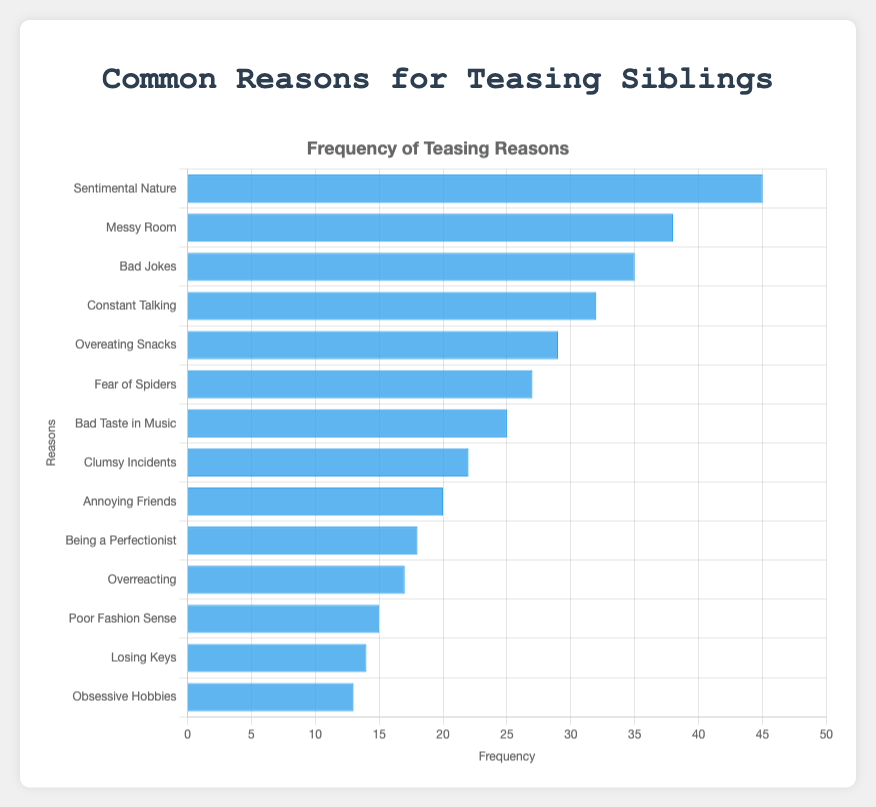Which reason is the most common for teasing siblings? The reason "Sentimental Nature" has the highest bar in the chart, indicating it has the highest frequency of 45.
Answer: Sentimental Nature What is the difference in occurrence frequency between "Sentimental Nature" and "Overreacting"? "Sentimental Nature" has a frequency of 45 and "Overreacting" has a frequency of 17. Subtracting 17 from 45 gives 28.
Answer: 28 What are the three least common reasons for teasing siblings? From the chart, the reasons with the smallest bars are "Obsessive Hobbies", "Losing Keys", and "Poor Fashion Sense" with frequencies of 13, 14, and 15, respectively.
Answer: Obsessive Hobbies, Losing Keys, Poor Fashion Sense How much more frequently is "Messy Room" teased compared to "Fear of Spiders"? The frequency of "Messy Room" is 38, while the frequency of "Fear of Spiders" is 27. The difference is 38 - 27 = 11.
Answer: 11 Which reason is teased more, "Bad Jokes" or "Constant Talking"? The bar for "Bad Jokes" is higher than the bar for "Constant Talking." "Bad Jokes" has a frequency of 35, whereas "Constant Talking" has a frequency of 32.
Answer: Bad Jokes What is the total frequency for the top 3 reasons for teasing siblings? The top 3 reasons are "Sentimental Nature" (45), "Messy Room" (38), and "Bad Jokes" (35). The total is 45 + 38 + 35 = 118.
Answer: 118 Is "Overeating Snacks" teased more frequently than "Clumsy Incidents"? The frequency of "Overeating Snacks" is 29, while the frequency for "Clumsy Incidents" is 22. Since 29 is greater than 22, "Overeating Snacks" is teased more frequently.
Answer: Yes What is the average frequency of all reasons listed? Sum all the frequencies and then divide by the number of reasons. The sum is 45+38+35+32+29+27+25+22+20+18+17+15+14+13 = 350. There are 14 reasons, so the average is 350/14 ≈ 25.
Answer: 25 Which reason falls in the middle (median) in terms of frequency? Listing the frequencies in ascending order: 13, 14, 15, 17, 18, 20, 22, 25, 27, 29, 32, 35, 38, 45. The median is the average of the 7th and 8th values: (22+25)/2 = 23.5.
Answer: 23.5 What is the combined frequency of the reasons that have a frequency above 30? The reasons are "Sentimental Nature" (45), "Messy Room" (38), "Bad Jokes" (35), "Constant Talking" (32). The total is 45+38+35+32 = 150.
Answer: 150 